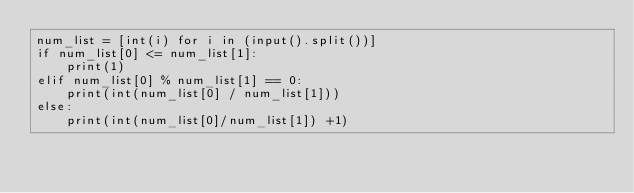Convert code to text. <code><loc_0><loc_0><loc_500><loc_500><_Python_>num_list = [int(i) for i in (input().split())]
if num_list[0] <= num_list[1]:
    print(1)
elif num_list[0] % num_list[1] == 0:
    print(int(num_list[0] / num_list[1]))
else:
    print(int(num_list[0]/num_list[1]) +1)</code> 